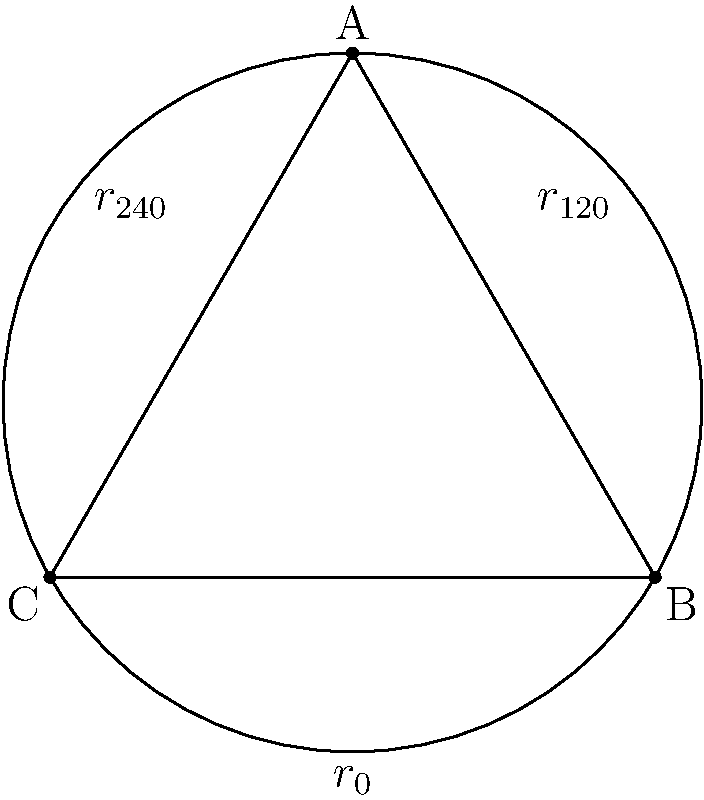In your research on historical accounts of ancient geometric understanding, you come across a first-hand description of a triangular artifact with perfect symmetry. The artifact is described as having rotational symmetries that form a group structure. Based on the diagram, which represents the symmetries of an equilateral triangle, how many distinct elements are in the rotation group of this triangle, and what is the order of the rotation $r_{120°}$? To answer this question, let's analyze the rotational symmetries of an equilateral triangle step-by-step:

1. Rotational symmetries of an equilateral triangle:
   - $r_{0°}$: Identity rotation (no rotation)
   - $r_{120°}$: Rotation by 120° clockwise
   - $r_{240°}$: Rotation by 240° clockwise (equivalent to 120° counterclockwise)

2. Number of distinct elements:
   There are 3 distinct rotations as listed above.

3. Group structure:
   These rotations form a group under composition, known as the cyclic group of order 3, often denoted as $C_3$ or $\mathbb{Z}_3$.

4. Order of $r_{120°}$:
   The order of an element in a group is the smallest positive integer $n$ such that $g^n = e$ (identity element).
   - $r_{120°} \circ r_{120°} = r_{240°}$
   - $r_{120°} \circ r_{120°} \circ r_{120°} = r_{0°}$ (identity)

   Therefore, the order of $r_{120°}$ is 3.

In the context of historical research, this mathematical analysis provides insight into the sophisticated geometric understanding that ancient civilizations may have possessed, as evidenced by the symmetrical properties of the described artifact.
Answer: 3 elements; order 3 